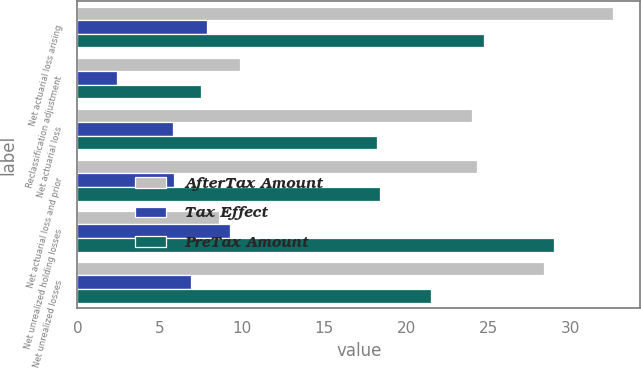Convert chart. <chart><loc_0><loc_0><loc_500><loc_500><stacked_bar_chart><ecel><fcel>Net actuarial loss arising<fcel>Reclassification adjustment<fcel>Net actuarial loss<fcel>Net actuarial loss and prior<fcel>Net unrealized holding losses<fcel>Net unrealized losses<nl><fcel>AfterTax Amount<fcel>32.6<fcel>9.9<fcel>24<fcel>24.3<fcel>8.6<fcel>28.4<nl><fcel>Tax Effect<fcel>7.9<fcel>2.4<fcel>5.8<fcel>5.9<fcel>9.3<fcel>6.9<nl><fcel>PreTax Amount<fcel>24.7<fcel>7.5<fcel>18.2<fcel>18.4<fcel>29<fcel>21.5<nl></chart> 